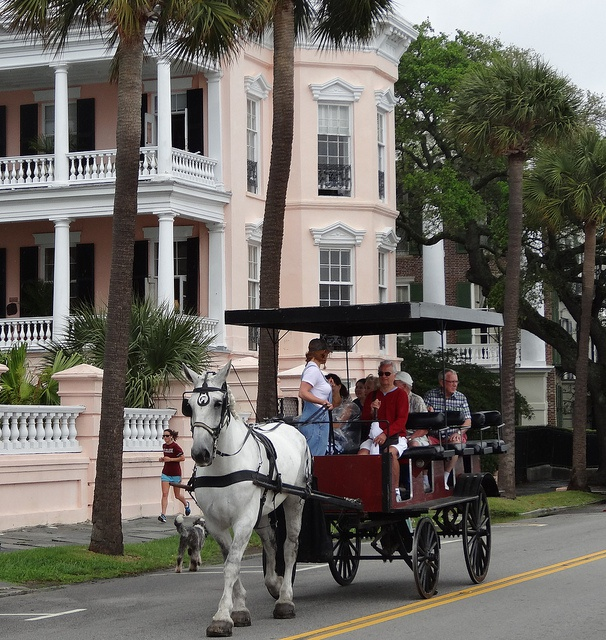Describe the objects in this image and their specific colors. I can see horse in darkgray, gray, black, and lightgray tones, people in darkgray, maroon, black, brown, and lavender tones, people in darkgray, gray, black, and lavender tones, people in darkgray, black, gray, and maroon tones, and people in darkgray, black, gray, and maroon tones in this image. 